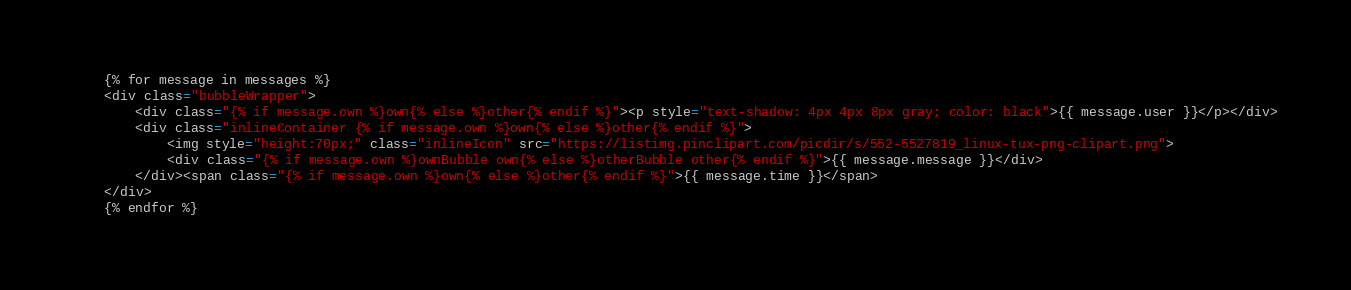Convert code to text. <code><loc_0><loc_0><loc_500><loc_500><_HTML_>    {% for message in messages %}
    <div class="bubbleWrapper">
        <div class="{% if message.own %}own{% else %}other{% endif %}"><p style="text-shadow: 4px 4px 8px gray; color: black">{{ message.user }}</p></div>
		<div class="inlineContainer {% if message.own %}own{% else %}other{% endif %}">
			<img style="height:70px;" class="inlineIcon" src="https://listimg.pinclipart.com/picdir/s/552-5527819_linux-tux-png-clipart.png">
			<div class="{% if message.own %}ownBubble own{% else %}otherBubble other{% endif %}">{{ message.message }}</div>
		</div><span class="{% if message.own %}own{% else %}other{% endif %}">{{ message.time }}</span>
	</div>
    {% endfor %}

</code> 